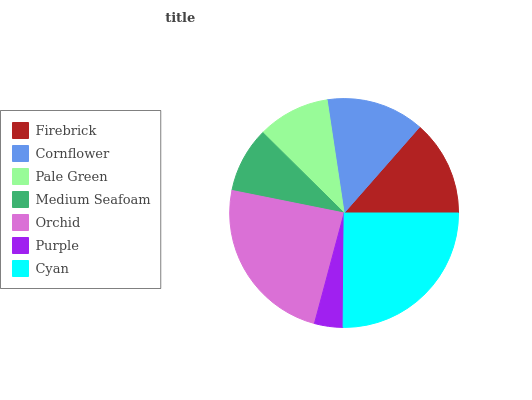Is Purple the minimum?
Answer yes or no. Yes. Is Cyan the maximum?
Answer yes or no. Yes. Is Cornflower the minimum?
Answer yes or no. No. Is Cornflower the maximum?
Answer yes or no. No. Is Cornflower greater than Firebrick?
Answer yes or no. Yes. Is Firebrick less than Cornflower?
Answer yes or no. Yes. Is Firebrick greater than Cornflower?
Answer yes or no. No. Is Cornflower less than Firebrick?
Answer yes or no. No. Is Firebrick the high median?
Answer yes or no. Yes. Is Firebrick the low median?
Answer yes or no. Yes. Is Purple the high median?
Answer yes or no. No. Is Cornflower the low median?
Answer yes or no. No. 